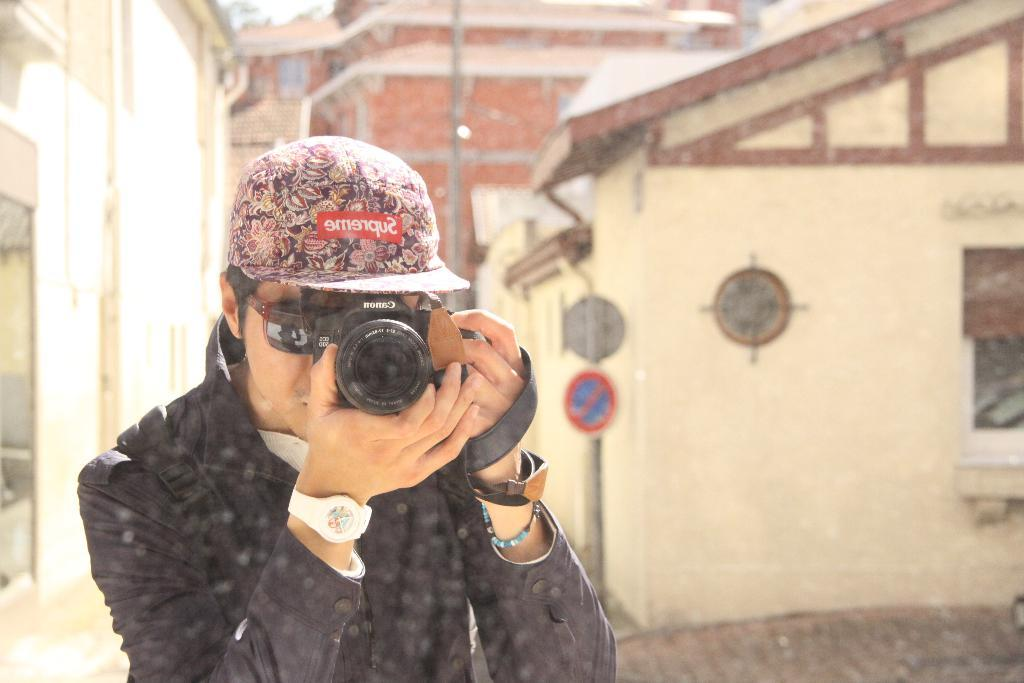Who is present in the image? There is a man in the image. What is the man holding in his hand? The man is holding a camera in his hand. What can be seen in the background of the image? There are sign boards, poles, and buildings in the background of the image. How many spiders are crawling on the man's face in the image? There are no spiders present in the image, so it is not possible to determine how many might be crawling on the man's face. 